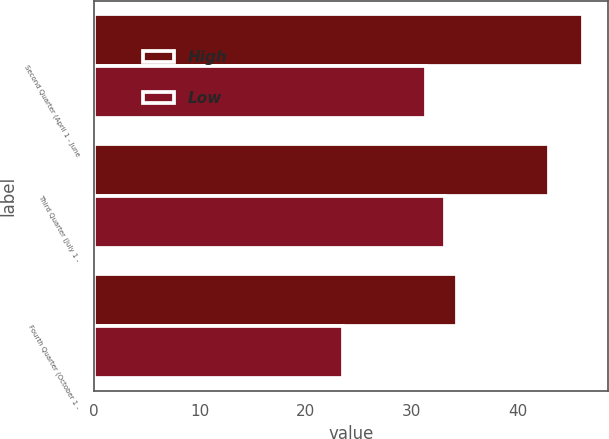Convert chart. <chart><loc_0><loc_0><loc_500><loc_500><stacked_bar_chart><ecel><fcel>Second Quarter (April 1 - June<fcel>Third Quarter (July 1 -<fcel>Fourth Quarter (October 1 -<nl><fcel>High<fcel>46.2<fcel>42.94<fcel>34.29<nl><fcel>Low<fcel>31.31<fcel>33.16<fcel>23.51<nl></chart> 